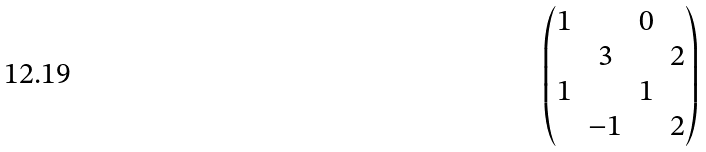<formula> <loc_0><loc_0><loc_500><loc_500>\begin{pmatrix} 1 & & 0 & \\ & 3 & & 2 \\ 1 & & 1 & \\ & - 1 & & 2 \end{pmatrix}</formula> 